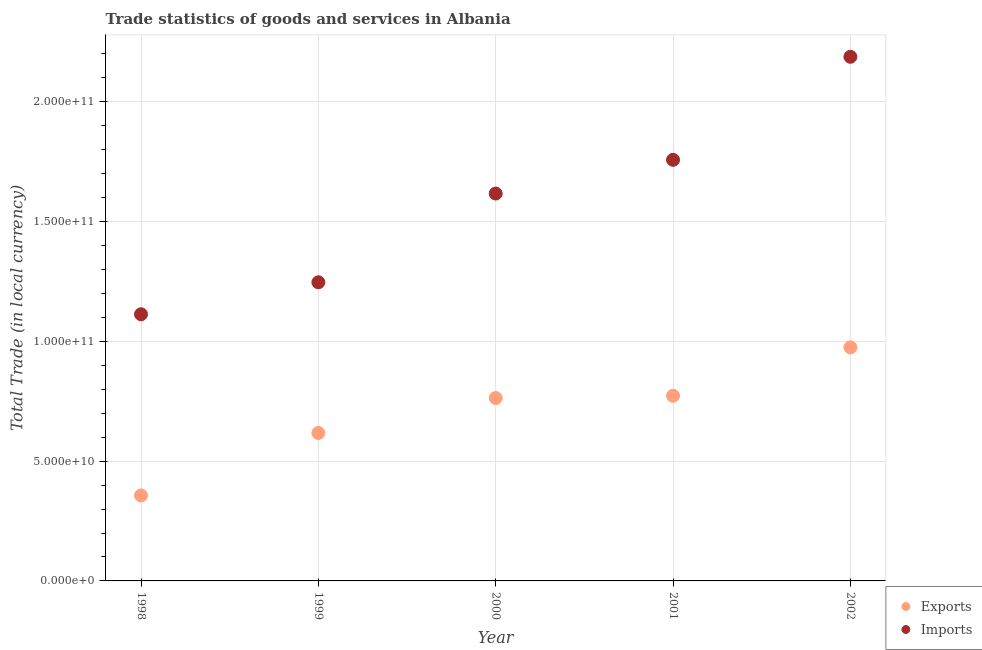What is the export of goods and services in 2000?
Offer a very short reply. 7.63e+1. Across all years, what is the maximum imports of goods and services?
Ensure brevity in your answer.  2.19e+11. Across all years, what is the minimum export of goods and services?
Offer a very short reply. 3.57e+1. In which year was the export of goods and services maximum?
Offer a terse response. 2002. In which year was the export of goods and services minimum?
Keep it short and to the point. 1998. What is the total export of goods and services in the graph?
Your answer should be very brief. 3.49e+11. What is the difference between the export of goods and services in 1998 and that in 2002?
Offer a very short reply. -6.18e+1. What is the difference between the imports of goods and services in 2001 and the export of goods and services in 2002?
Your answer should be compact. 7.83e+1. What is the average export of goods and services per year?
Your response must be concise. 6.97e+1. In the year 2002, what is the difference between the imports of goods and services and export of goods and services?
Offer a very short reply. 1.21e+11. What is the ratio of the imports of goods and services in 2001 to that in 2002?
Make the answer very short. 0.8. Is the export of goods and services in 1998 less than that in 2000?
Your answer should be compact. Yes. Is the difference between the imports of goods and services in 1998 and 2000 greater than the difference between the export of goods and services in 1998 and 2000?
Offer a very short reply. No. What is the difference between the highest and the second highest imports of goods and services?
Offer a very short reply. 4.30e+1. What is the difference between the highest and the lowest imports of goods and services?
Offer a very short reply. 1.07e+11. In how many years, is the imports of goods and services greater than the average imports of goods and services taken over all years?
Provide a short and direct response. 3. Does the export of goods and services monotonically increase over the years?
Your response must be concise. Yes. Is the export of goods and services strictly greater than the imports of goods and services over the years?
Give a very brief answer. No. Is the export of goods and services strictly less than the imports of goods and services over the years?
Keep it short and to the point. Yes. How many dotlines are there?
Your answer should be compact. 2. How many years are there in the graph?
Ensure brevity in your answer.  5. Does the graph contain any zero values?
Your answer should be compact. No. Where does the legend appear in the graph?
Offer a terse response. Bottom right. How many legend labels are there?
Make the answer very short. 2. What is the title of the graph?
Your answer should be very brief. Trade statistics of goods and services in Albania. Does "Automatic Teller Machines" appear as one of the legend labels in the graph?
Keep it short and to the point. No. What is the label or title of the Y-axis?
Offer a very short reply. Total Trade (in local currency). What is the Total Trade (in local currency) in Exports in 1998?
Offer a terse response. 3.57e+1. What is the Total Trade (in local currency) of Imports in 1998?
Provide a succinct answer. 1.11e+11. What is the Total Trade (in local currency) in Exports in 1999?
Your answer should be compact. 6.18e+1. What is the Total Trade (in local currency) in Imports in 1999?
Provide a succinct answer. 1.25e+11. What is the Total Trade (in local currency) of Exports in 2000?
Offer a terse response. 7.63e+1. What is the Total Trade (in local currency) in Imports in 2000?
Make the answer very short. 1.62e+11. What is the Total Trade (in local currency) in Exports in 2001?
Your response must be concise. 7.73e+1. What is the Total Trade (in local currency) in Imports in 2001?
Make the answer very short. 1.76e+11. What is the Total Trade (in local currency) of Exports in 2002?
Provide a succinct answer. 9.75e+1. What is the Total Trade (in local currency) of Imports in 2002?
Keep it short and to the point. 2.19e+11. Across all years, what is the maximum Total Trade (in local currency) of Exports?
Give a very brief answer. 9.75e+1. Across all years, what is the maximum Total Trade (in local currency) of Imports?
Your response must be concise. 2.19e+11. Across all years, what is the minimum Total Trade (in local currency) in Exports?
Your answer should be very brief. 3.57e+1. Across all years, what is the minimum Total Trade (in local currency) in Imports?
Your answer should be very brief. 1.11e+11. What is the total Total Trade (in local currency) of Exports in the graph?
Offer a terse response. 3.49e+11. What is the total Total Trade (in local currency) in Imports in the graph?
Keep it short and to the point. 7.92e+11. What is the difference between the Total Trade (in local currency) in Exports in 1998 and that in 1999?
Keep it short and to the point. -2.61e+1. What is the difference between the Total Trade (in local currency) in Imports in 1998 and that in 1999?
Keep it short and to the point. -1.34e+1. What is the difference between the Total Trade (in local currency) in Exports in 1998 and that in 2000?
Your response must be concise. -4.07e+1. What is the difference between the Total Trade (in local currency) of Imports in 1998 and that in 2000?
Your answer should be compact. -5.04e+1. What is the difference between the Total Trade (in local currency) in Exports in 1998 and that in 2001?
Offer a very short reply. -4.16e+1. What is the difference between the Total Trade (in local currency) in Imports in 1998 and that in 2001?
Provide a succinct answer. -6.45e+1. What is the difference between the Total Trade (in local currency) in Exports in 1998 and that in 2002?
Keep it short and to the point. -6.18e+1. What is the difference between the Total Trade (in local currency) of Imports in 1998 and that in 2002?
Keep it short and to the point. -1.07e+11. What is the difference between the Total Trade (in local currency) in Exports in 1999 and that in 2000?
Make the answer very short. -1.46e+1. What is the difference between the Total Trade (in local currency) of Imports in 1999 and that in 2000?
Give a very brief answer. -3.70e+1. What is the difference between the Total Trade (in local currency) of Exports in 1999 and that in 2001?
Ensure brevity in your answer.  -1.55e+1. What is the difference between the Total Trade (in local currency) in Imports in 1999 and that in 2001?
Your answer should be very brief. -5.11e+1. What is the difference between the Total Trade (in local currency) of Exports in 1999 and that in 2002?
Give a very brief answer. -3.57e+1. What is the difference between the Total Trade (in local currency) in Imports in 1999 and that in 2002?
Offer a terse response. -9.41e+1. What is the difference between the Total Trade (in local currency) of Exports in 2000 and that in 2001?
Your response must be concise. -9.52e+08. What is the difference between the Total Trade (in local currency) in Imports in 2000 and that in 2001?
Provide a succinct answer. -1.41e+1. What is the difference between the Total Trade (in local currency) in Exports in 2000 and that in 2002?
Keep it short and to the point. -2.12e+1. What is the difference between the Total Trade (in local currency) of Imports in 2000 and that in 2002?
Your response must be concise. -5.71e+1. What is the difference between the Total Trade (in local currency) in Exports in 2001 and that in 2002?
Ensure brevity in your answer.  -2.02e+1. What is the difference between the Total Trade (in local currency) in Imports in 2001 and that in 2002?
Provide a succinct answer. -4.30e+1. What is the difference between the Total Trade (in local currency) in Exports in 1998 and the Total Trade (in local currency) in Imports in 1999?
Ensure brevity in your answer.  -8.90e+1. What is the difference between the Total Trade (in local currency) of Exports in 1998 and the Total Trade (in local currency) of Imports in 2000?
Offer a very short reply. -1.26e+11. What is the difference between the Total Trade (in local currency) of Exports in 1998 and the Total Trade (in local currency) of Imports in 2001?
Give a very brief answer. -1.40e+11. What is the difference between the Total Trade (in local currency) of Exports in 1998 and the Total Trade (in local currency) of Imports in 2002?
Keep it short and to the point. -1.83e+11. What is the difference between the Total Trade (in local currency) of Exports in 1999 and the Total Trade (in local currency) of Imports in 2000?
Offer a very short reply. -9.99e+1. What is the difference between the Total Trade (in local currency) of Exports in 1999 and the Total Trade (in local currency) of Imports in 2001?
Keep it short and to the point. -1.14e+11. What is the difference between the Total Trade (in local currency) in Exports in 1999 and the Total Trade (in local currency) in Imports in 2002?
Keep it short and to the point. -1.57e+11. What is the difference between the Total Trade (in local currency) of Exports in 2000 and the Total Trade (in local currency) of Imports in 2001?
Your answer should be very brief. -9.94e+1. What is the difference between the Total Trade (in local currency) of Exports in 2000 and the Total Trade (in local currency) of Imports in 2002?
Ensure brevity in your answer.  -1.42e+11. What is the difference between the Total Trade (in local currency) of Exports in 2001 and the Total Trade (in local currency) of Imports in 2002?
Provide a short and direct response. -1.41e+11. What is the average Total Trade (in local currency) of Exports per year?
Offer a terse response. 6.97e+1. What is the average Total Trade (in local currency) of Imports per year?
Your answer should be very brief. 1.58e+11. In the year 1998, what is the difference between the Total Trade (in local currency) of Exports and Total Trade (in local currency) of Imports?
Offer a very short reply. -7.56e+1. In the year 1999, what is the difference between the Total Trade (in local currency) in Exports and Total Trade (in local currency) in Imports?
Give a very brief answer. -6.29e+1. In the year 2000, what is the difference between the Total Trade (in local currency) in Exports and Total Trade (in local currency) in Imports?
Your answer should be compact. -8.54e+1. In the year 2001, what is the difference between the Total Trade (in local currency) in Exports and Total Trade (in local currency) in Imports?
Offer a very short reply. -9.85e+1. In the year 2002, what is the difference between the Total Trade (in local currency) of Exports and Total Trade (in local currency) of Imports?
Make the answer very short. -1.21e+11. What is the ratio of the Total Trade (in local currency) in Exports in 1998 to that in 1999?
Your response must be concise. 0.58. What is the ratio of the Total Trade (in local currency) in Imports in 1998 to that in 1999?
Your response must be concise. 0.89. What is the ratio of the Total Trade (in local currency) of Exports in 1998 to that in 2000?
Offer a terse response. 0.47. What is the ratio of the Total Trade (in local currency) in Imports in 1998 to that in 2000?
Give a very brief answer. 0.69. What is the ratio of the Total Trade (in local currency) of Exports in 1998 to that in 2001?
Ensure brevity in your answer.  0.46. What is the ratio of the Total Trade (in local currency) of Imports in 1998 to that in 2001?
Ensure brevity in your answer.  0.63. What is the ratio of the Total Trade (in local currency) in Exports in 1998 to that in 2002?
Provide a succinct answer. 0.37. What is the ratio of the Total Trade (in local currency) of Imports in 1998 to that in 2002?
Offer a terse response. 0.51. What is the ratio of the Total Trade (in local currency) in Exports in 1999 to that in 2000?
Your answer should be very brief. 0.81. What is the ratio of the Total Trade (in local currency) in Imports in 1999 to that in 2000?
Make the answer very short. 0.77. What is the ratio of the Total Trade (in local currency) of Exports in 1999 to that in 2001?
Make the answer very short. 0.8. What is the ratio of the Total Trade (in local currency) of Imports in 1999 to that in 2001?
Offer a very short reply. 0.71. What is the ratio of the Total Trade (in local currency) of Exports in 1999 to that in 2002?
Offer a very short reply. 0.63. What is the ratio of the Total Trade (in local currency) in Imports in 1999 to that in 2002?
Your response must be concise. 0.57. What is the ratio of the Total Trade (in local currency) of Exports in 2000 to that in 2001?
Offer a very short reply. 0.99. What is the ratio of the Total Trade (in local currency) of Imports in 2000 to that in 2001?
Your answer should be compact. 0.92. What is the ratio of the Total Trade (in local currency) of Exports in 2000 to that in 2002?
Give a very brief answer. 0.78. What is the ratio of the Total Trade (in local currency) in Imports in 2000 to that in 2002?
Your response must be concise. 0.74. What is the ratio of the Total Trade (in local currency) of Exports in 2001 to that in 2002?
Offer a very short reply. 0.79. What is the ratio of the Total Trade (in local currency) of Imports in 2001 to that in 2002?
Offer a terse response. 0.8. What is the difference between the highest and the second highest Total Trade (in local currency) in Exports?
Provide a succinct answer. 2.02e+1. What is the difference between the highest and the second highest Total Trade (in local currency) in Imports?
Offer a terse response. 4.30e+1. What is the difference between the highest and the lowest Total Trade (in local currency) in Exports?
Offer a terse response. 6.18e+1. What is the difference between the highest and the lowest Total Trade (in local currency) of Imports?
Your answer should be very brief. 1.07e+11. 